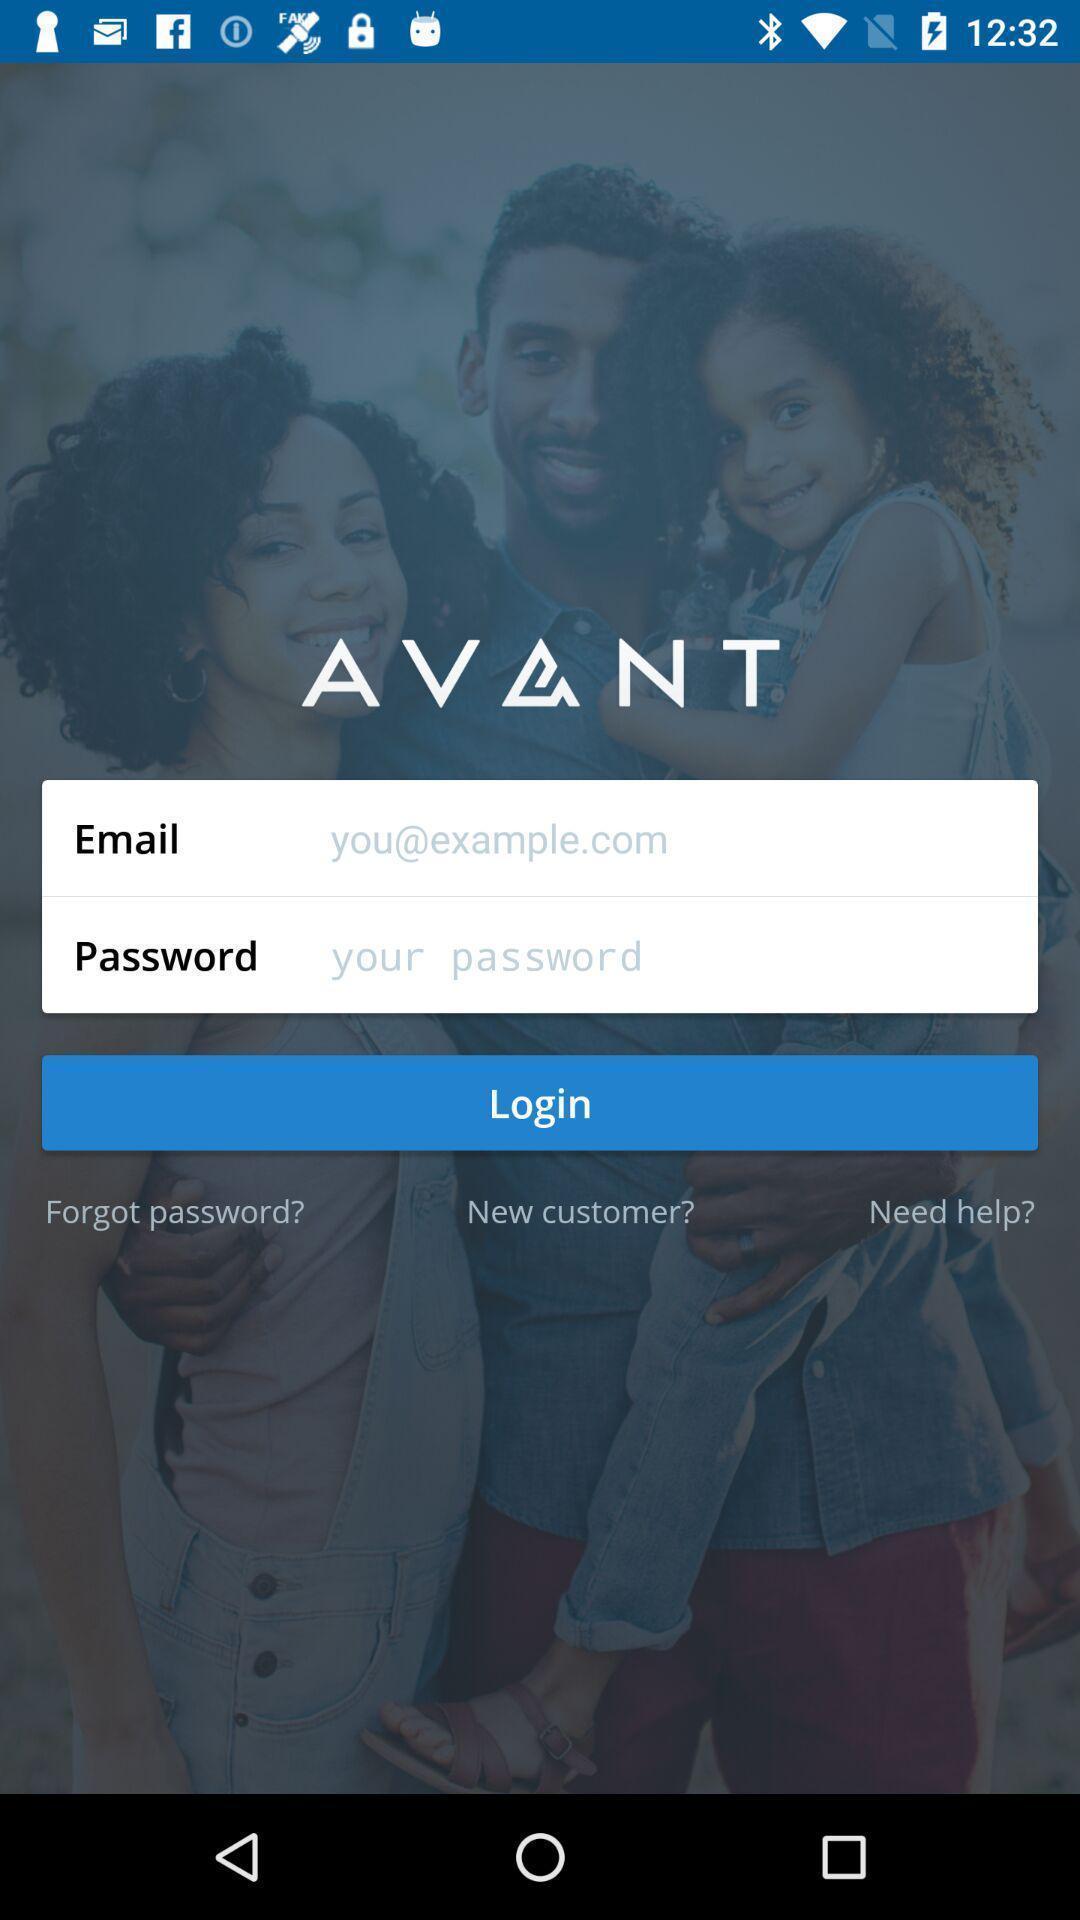Give me a summary of this screen capture. Login page. 